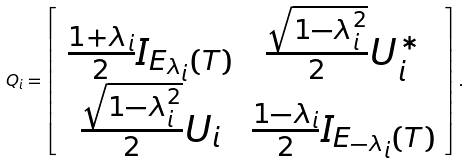Convert formula to latex. <formula><loc_0><loc_0><loc_500><loc_500>Q _ { i } = \left [ \begin{array} { c c } \frac { 1 + \lambda _ { i } } { 2 } I _ { E _ { \lambda _ { i } } ( T ) } & \frac { \sqrt { 1 - \lambda _ { i } ^ { 2 } } } { 2 } U _ { i } ^ { * } \\ \frac { \sqrt { 1 - \lambda _ { i } ^ { 2 } } } { 2 } U _ { i } & \frac { 1 - \lambda _ { i } } { 2 } I _ { E _ { - \lambda _ { i } } ( T ) } \end{array} \right ] .</formula> 